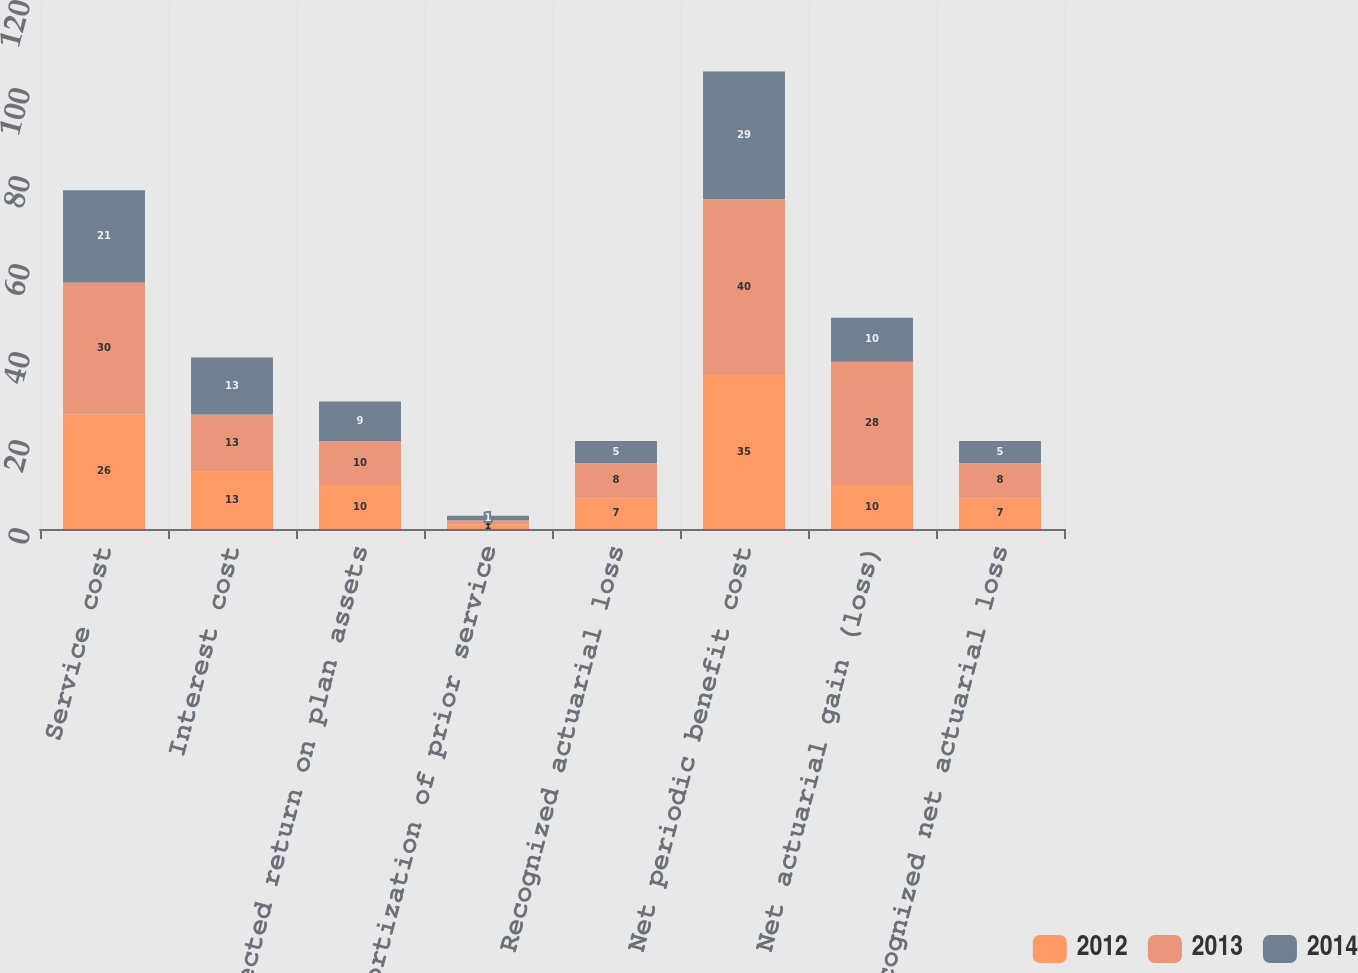Convert chart. <chart><loc_0><loc_0><loc_500><loc_500><stacked_bar_chart><ecel><fcel>Service cost<fcel>Interest cost<fcel>Expected return on plan assets<fcel>Amortization of prior service<fcel>Recognized actuarial loss<fcel>Net periodic benefit cost<fcel>Net actuarial gain (loss)<fcel>Recognized net actuarial loss<nl><fcel>2012<fcel>26<fcel>13<fcel>10<fcel>1<fcel>7<fcel>35<fcel>10<fcel>7<nl><fcel>2013<fcel>30<fcel>13<fcel>10<fcel>1<fcel>8<fcel>40<fcel>28<fcel>8<nl><fcel>2014<fcel>21<fcel>13<fcel>9<fcel>1<fcel>5<fcel>29<fcel>10<fcel>5<nl></chart> 